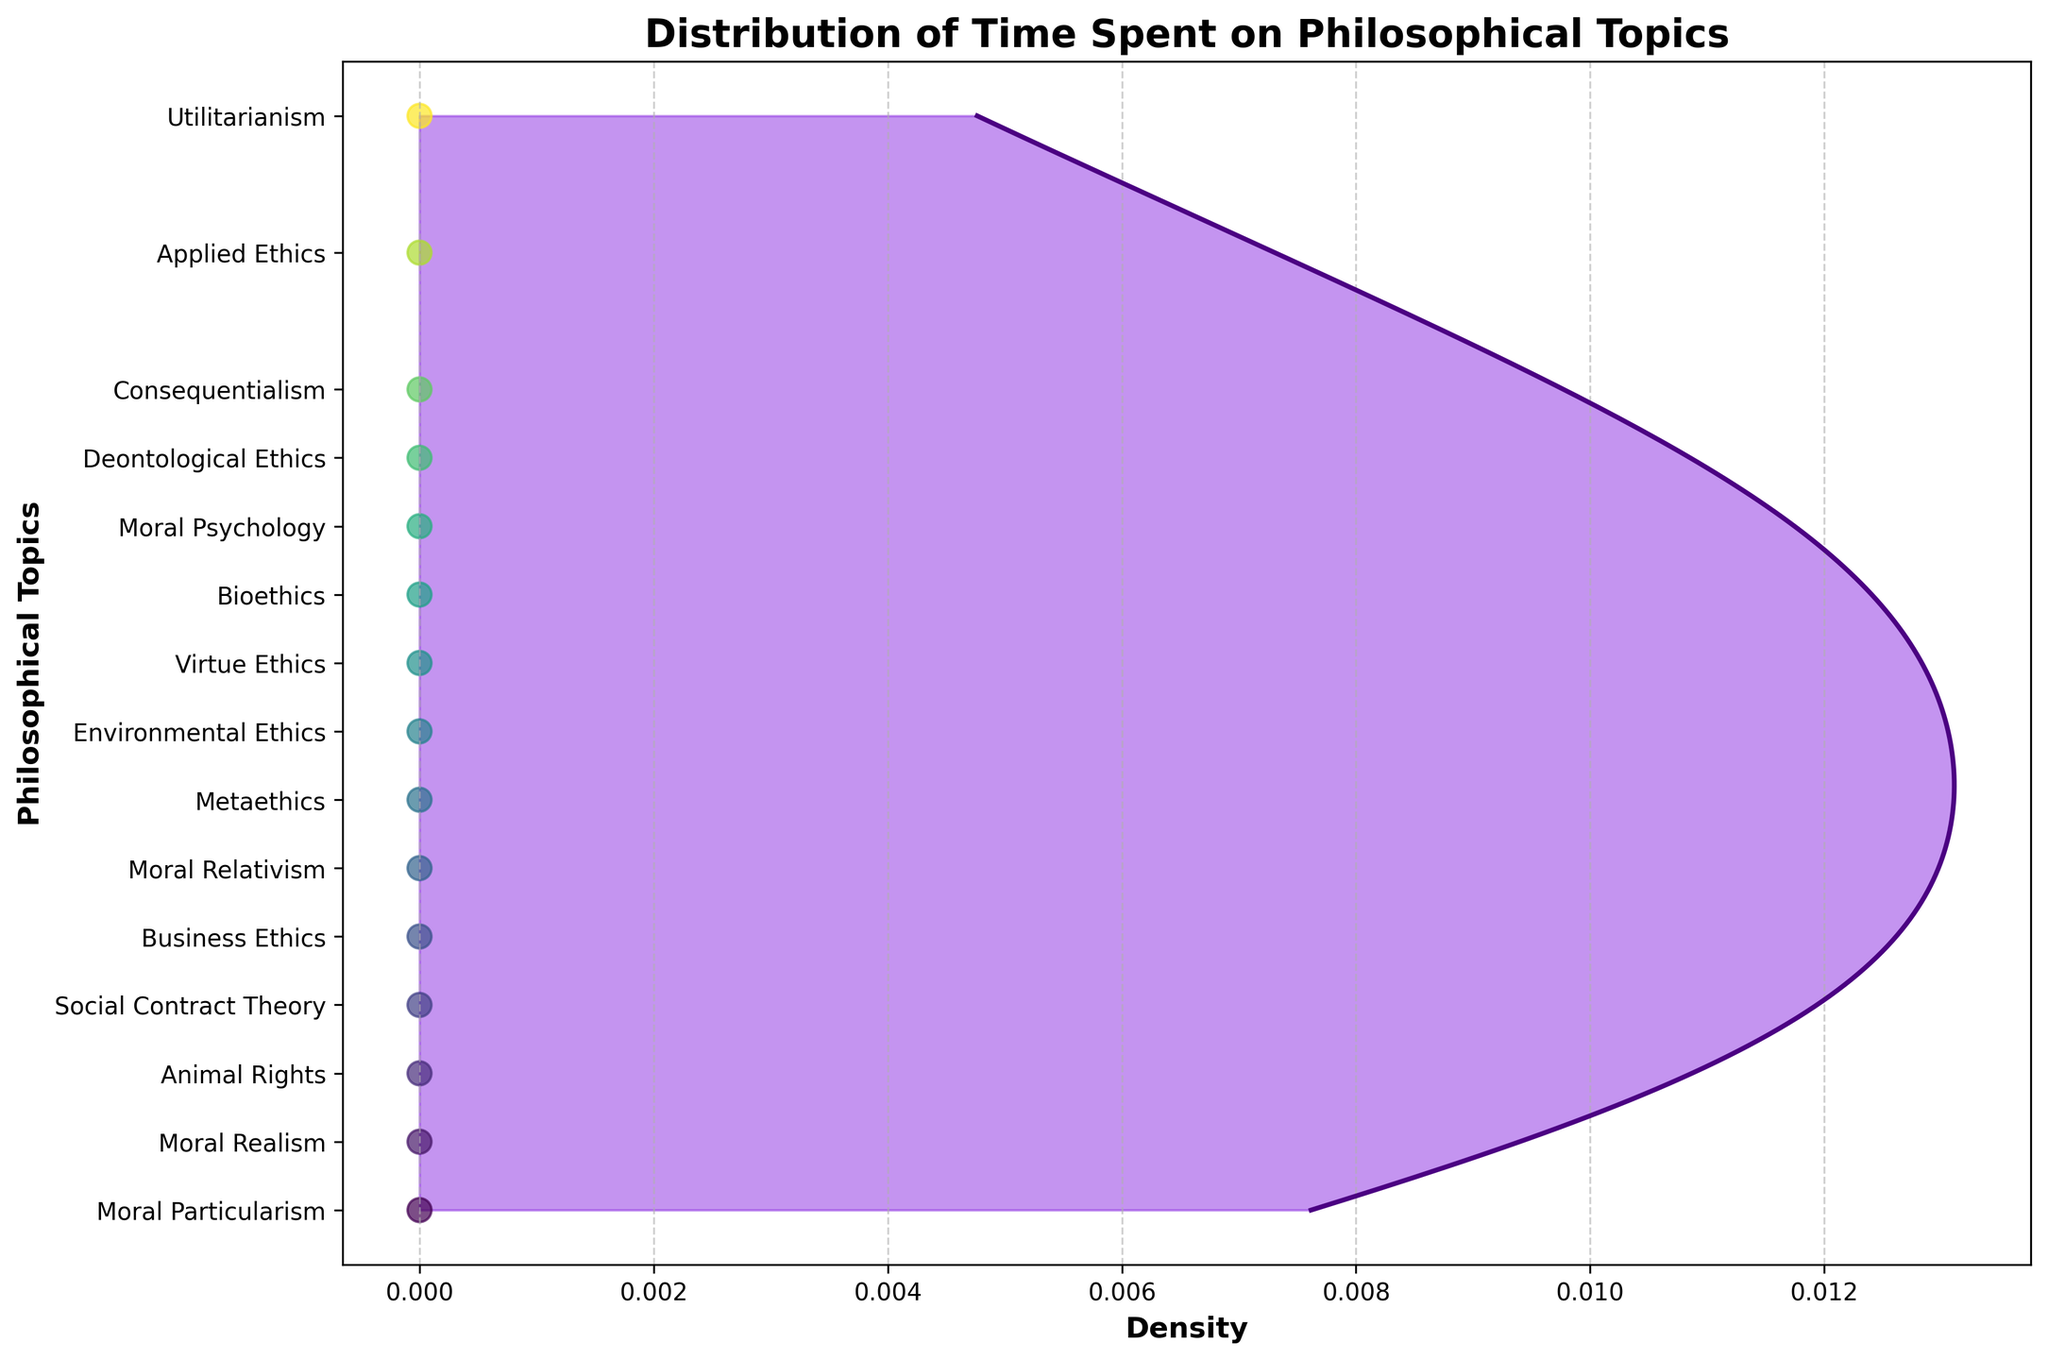what is the title of the plot? The title is located at the top of the figure in a larger, bold font. It concisely describes the content of the plot. The title is "Distribution of Time Spent on Philosophical Topics".
Answer: Distribution of Time Spent on Philosophical Topics What is the range of hours spent on philosophical topics? The range of hours can be determined by looking at the y-axis, which lists the hours for each topic. The minimum value is 40 (Moral Particularism) and the maximum value is 120 (Utilitarianism).
Answer: 40 to 120 Which philosophical topic has the highest time spent? By locating the highest point on the y-axis and the corresponding topic label, we see that Utilitarianism has the highest value.
Answer: Utilitarianism How many philosophical topics have less than 60 hours spent? Count the number of topics on the y-axis with values less than 60. The topics are Business Ethics, Social Contract Theory, Animal Rights, Moral Realism, and Moral Particularism.
Answer: 5 What is the total time spent on Deontological Ethics and Virtue Ethics? Add the hours spent on Deontological Ethics (95) and Virtue Ethics (80). The sum is 95 + 80 = 175.
Answer: 175 Which topic has more time spent: Metaethics or Bioethics? Compare the hours spent on Metaethics (70) and Bioethics (85). Bioethics has more time spent.
Answer: Bioethics What is the average time spent on Applied Ethics, Bioethics, Environmental Ethics, and Business Ethics? Sum their hours: 110 (Applied Ethics) + 85 (Bioethics) + 75 (Environmental Ethics) + 60 (Business Ethics) = 330. Divide by the number of topics: 330 / 4 = 82.5.
Answer: 82.5 Which two topics have the closest time spent? Compare the hours spent and identify the two closest values: Metaethics (70) and Environmental Ethics (75), with a difference of 5 hours.
Answer: Metaethics and Environmental Ethics What is the most densely populated range of hours based on the KDE plot? Observe where the density plot peaks. The most densely populated range is around 85-100 hours.
Answer: 85-100 hours Which topic has the least time spent? Locate the lowest point on the y-axis and the corresponding topic label, which is Moral Particularism with 40 hours.
Answer: Moral Particularism 